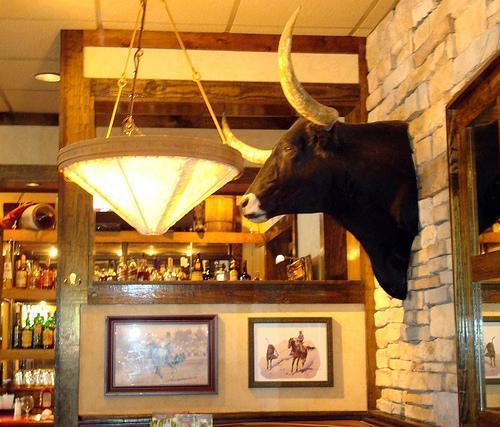How many bulls are there?
Give a very brief answer. 1. 